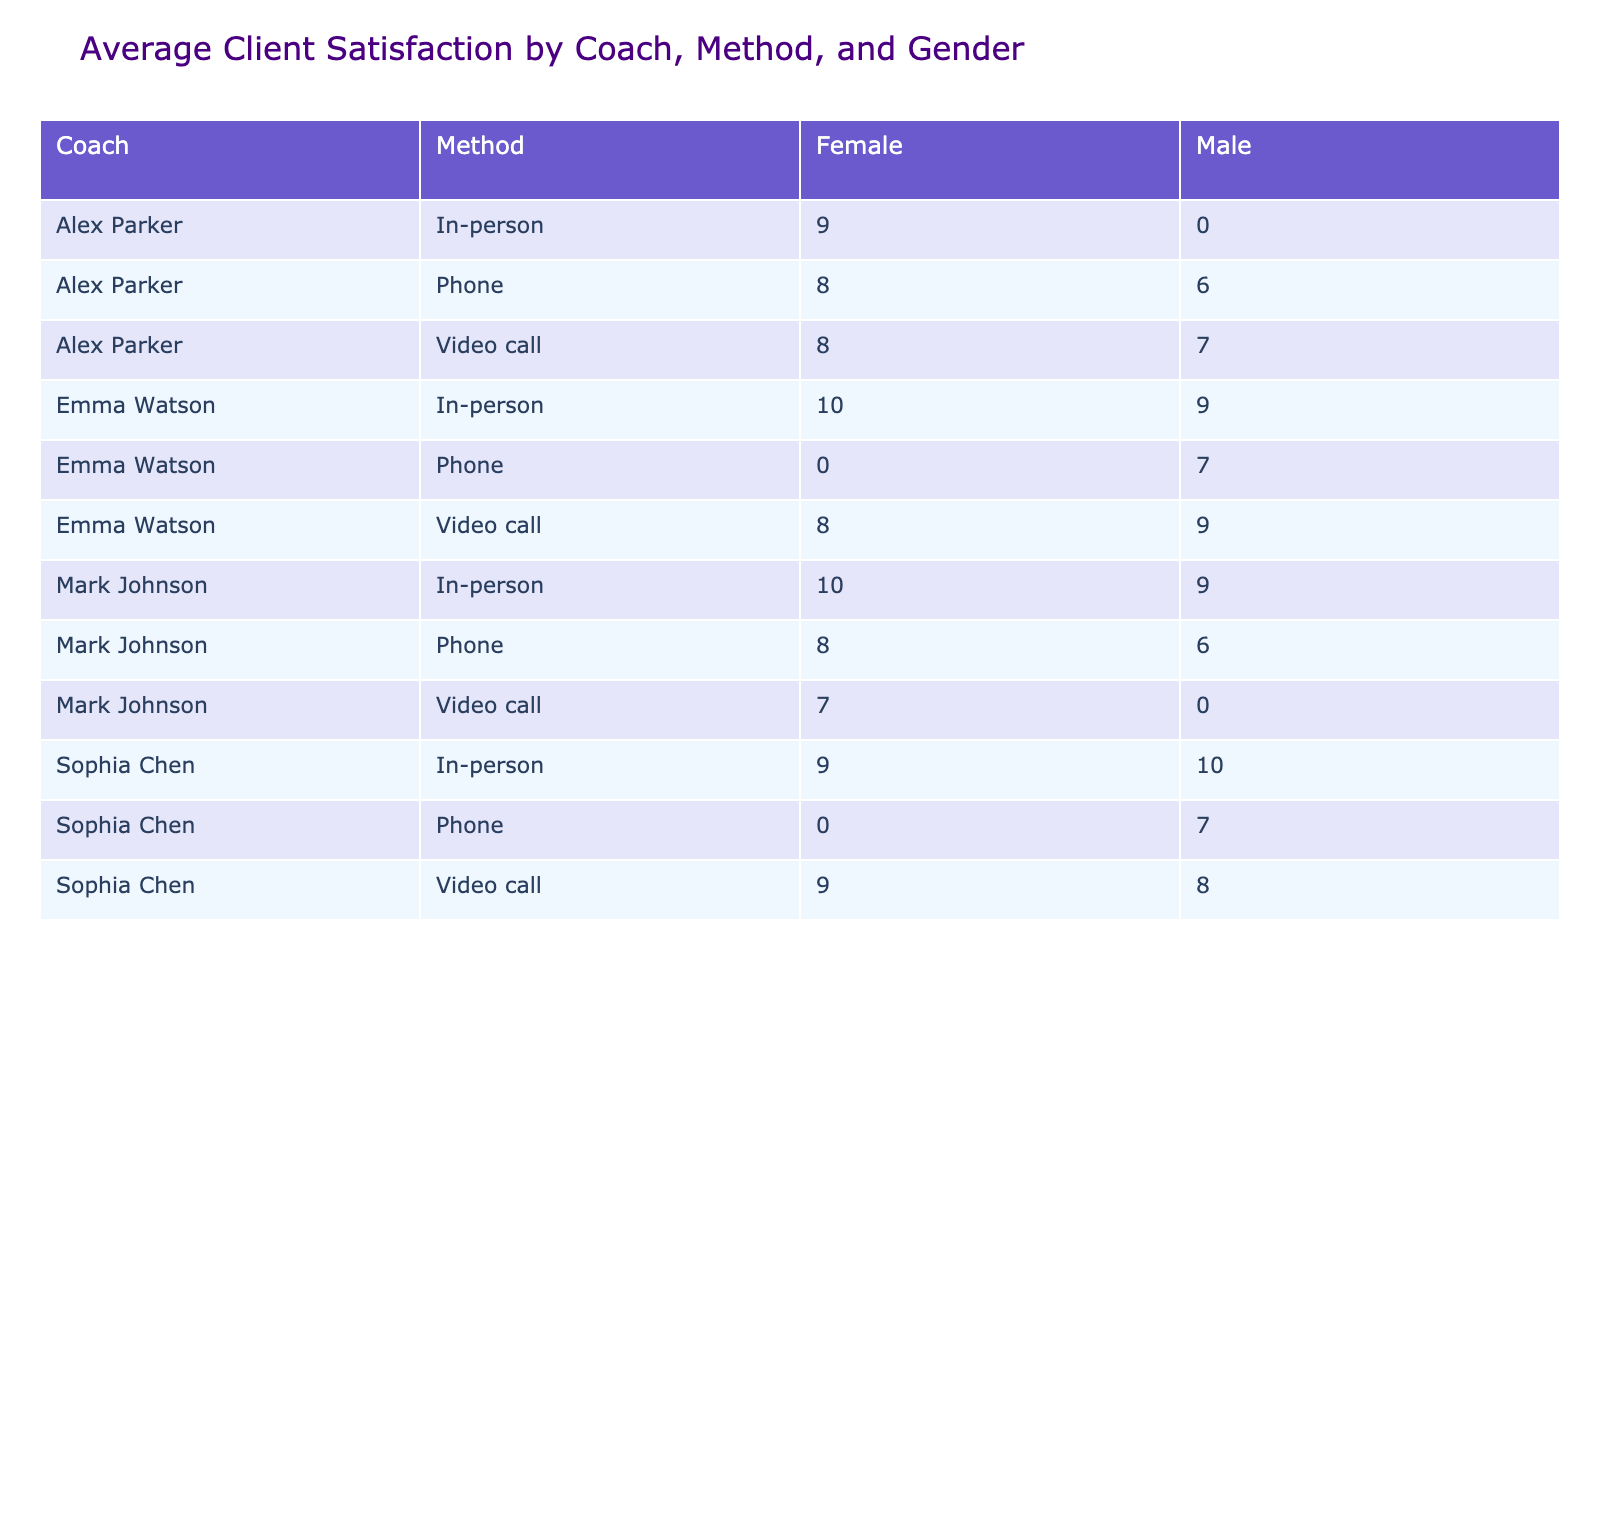What is the average satisfaction rating for in-person sessions by female clients? In the table, we look for the rows where the Method is "In-person" and Gender is "Female". These clients are Jessica Lee (10), Olivia Anderson (10), and Rachel Garcia (9). Summing these satisfaction ratings, we get 10 + 10 + 9 = 29. There are 3 data points, so the average is 29 / 3 = 9.67.
Answer: 9.67 Which coaching method received the highest satisfaction rating average from male clients? We analyze the average satisfaction ratings across all Methods for male clients. The ratings are: In-person (9.5, from Robert Taylor and Kevin Lewis), Video call (8, from David Wilson and Thomas Clark), and Phone (6, from Michael Brown and Christopher Martin). The highest average satisfaction rating for male clients is from the In-person method at an average of 9.5.
Answer: In-person Did any coaching method have clients rating their satisfaction as 'Low'? We check the satisfaction ratings and find the ratings for Phone and Video call methods. For the Phone method, Christopher Martin rated it 6 and for Video call, Amanda White rated it 7. Both ratings indicate "Low" satisfaction. Thus, there were instances of low satisfaction.
Answer: Yes What is the total number of clients who rated their satisfaction as 'High' using the Video call method? First, we look in the table for the Video call method and check the satisfaction ratings. The clients who rated satisfaction as 'High' are David Wilson (9) and Samantha Moore (9), so in total, there are 2 clients with 'High' ratings in the Video call method.
Answer: 2 Which coach had the highest overall average satisfaction across all methods? To find this, we calculate the average satisfaction ratings for each coach: Emma Watson has (9 + 8 + 7 + 10 + 9) / 5 = 8.6, Mark Johnson has (8 + 9 + 7 + 6 + 10) / 5 = 8.0, Sophia Chen has (8 + 9 + 7 + 9 + 10) / 5 = 8.6, and Alex Parker has (8 + 7 + 9 + 6 + 8) / 5 = 7.6. Both Emma Watson and Sophia Chen have the highest average satisfaction at 8.6.
Answer: Emma Watson and Sophia Chen What is the difference in average satisfaction ratings between in-person and phone methods for all clients? We first find the averages: In-person total ratings are (9 + 10 + 9 + 10) = 38 with 4 clients, so average is 38 / 4 = 9.5. For the Phone method, the total ratings are (7 + 8 + 6 + 6) = 27 with 4 clients, making the average 27 / 4 = 6.75. The difference in average is 9.5 - 6.75 = 2.75.
Answer: 2.75 